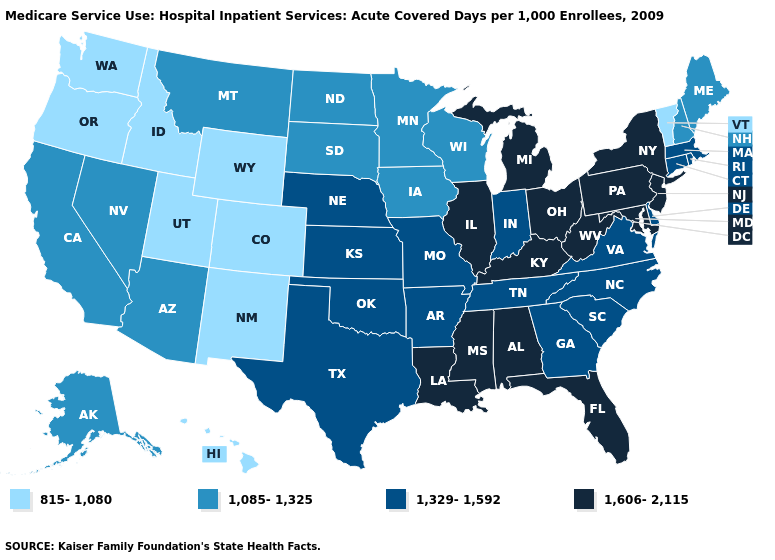How many symbols are there in the legend?
Concise answer only. 4. Which states have the lowest value in the West?
Keep it brief. Colorado, Hawaii, Idaho, New Mexico, Oregon, Utah, Washington, Wyoming. Does Mississippi have a lower value than Minnesota?
Be succinct. No. Name the states that have a value in the range 1,329-1,592?
Short answer required. Arkansas, Connecticut, Delaware, Georgia, Indiana, Kansas, Massachusetts, Missouri, Nebraska, North Carolina, Oklahoma, Rhode Island, South Carolina, Tennessee, Texas, Virginia. Does North Dakota have the same value as Wisconsin?
Keep it brief. Yes. What is the value of Indiana?
Be succinct. 1,329-1,592. What is the lowest value in the USA?
Answer briefly. 815-1,080. Name the states that have a value in the range 815-1,080?
Quick response, please. Colorado, Hawaii, Idaho, New Mexico, Oregon, Utah, Vermont, Washington, Wyoming. What is the highest value in states that border Pennsylvania?
Be succinct. 1,606-2,115. What is the value of Nevada?
Be succinct. 1,085-1,325. What is the value of Colorado?
Give a very brief answer. 815-1,080. How many symbols are there in the legend?
Short answer required. 4. Name the states that have a value in the range 1,085-1,325?
Give a very brief answer. Alaska, Arizona, California, Iowa, Maine, Minnesota, Montana, Nevada, New Hampshire, North Dakota, South Dakota, Wisconsin. Does the first symbol in the legend represent the smallest category?
Keep it brief. Yes. Does Vermont have the lowest value in the Northeast?
Write a very short answer. Yes. 